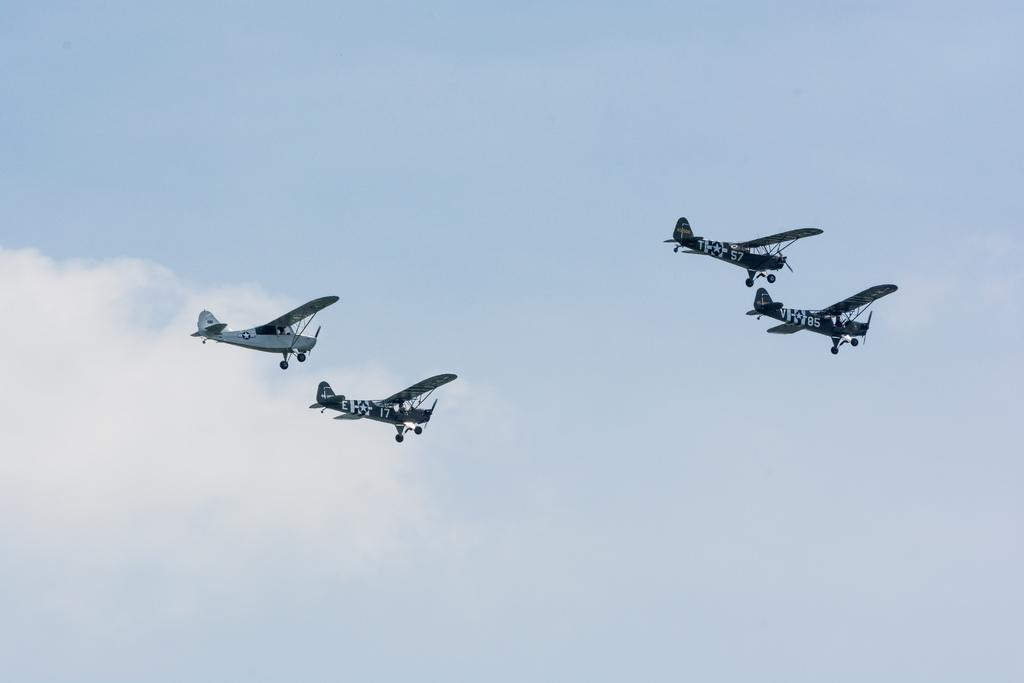What is happening in the image? There are airplanes flying in the image. What can be seen in the background of the image? The sky is visible in the background of the image. What is the condition of the sky in the image? Clouds are present in the sky. How does the wilderness affect the airplanes in the image? There is no wilderness present in the image; it features airplanes flying in the sky. 